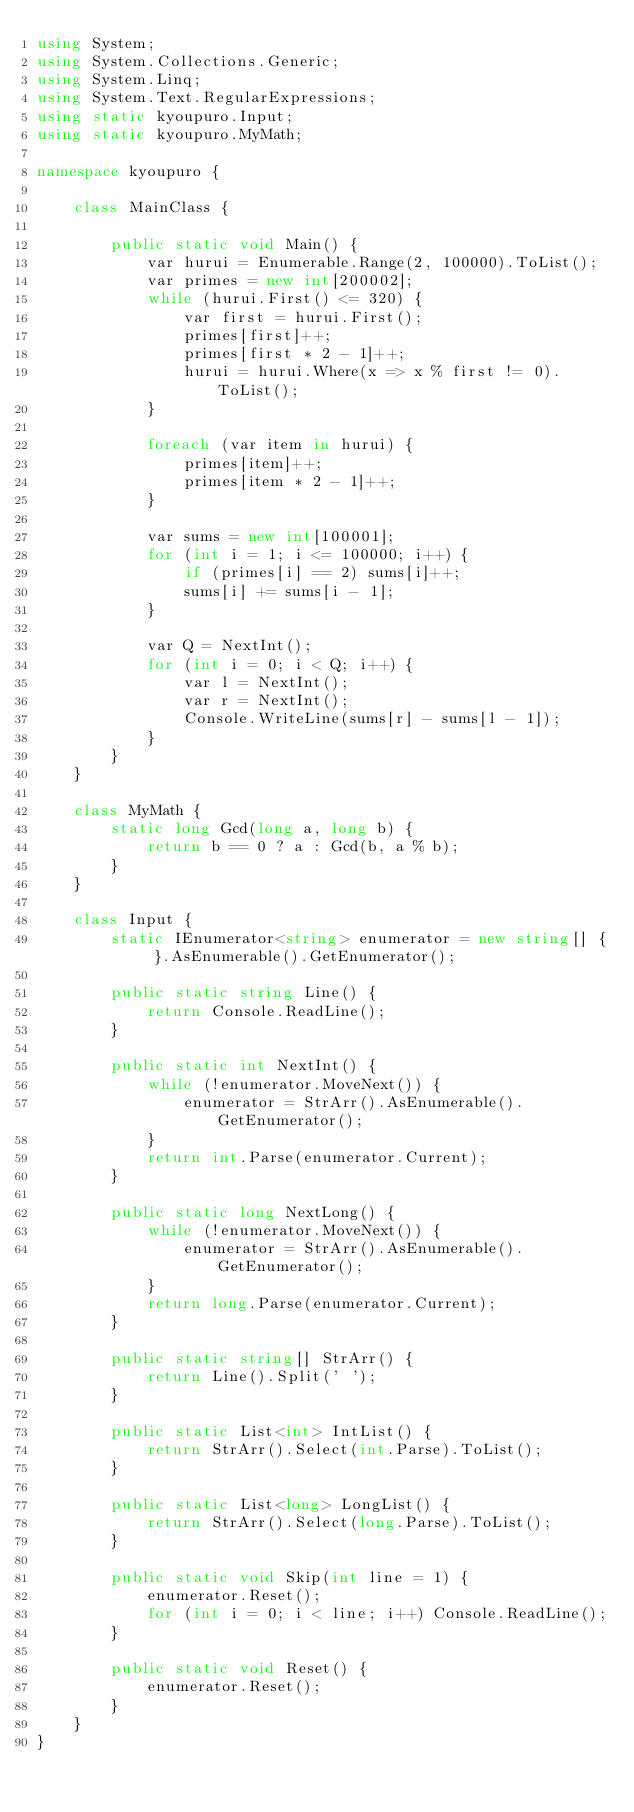Convert code to text. <code><loc_0><loc_0><loc_500><loc_500><_C#_>using System;
using System.Collections.Generic;
using System.Linq;
using System.Text.RegularExpressions;
using static kyoupuro.Input;
using static kyoupuro.MyMath;

namespace kyoupuro {

    class MainClass {

        public static void Main() {
            var hurui = Enumerable.Range(2, 100000).ToList();
            var primes = new int[200002];
            while (hurui.First() <= 320) {
                var first = hurui.First();
                primes[first]++;
                primes[first * 2 - 1]++;
                hurui = hurui.Where(x => x % first != 0).ToList();
            }

            foreach (var item in hurui) {
                primes[item]++;
                primes[item * 2 - 1]++;
            }

            var sums = new int[100001];
            for (int i = 1; i <= 100000; i++) {
                if (primes[i] == 2) sums[i]++;
                sums[i] += sums[i - 1];
            }

            var Q = NextInt();
            for (int i = 0; i < Q; i++) {
                var l = NextInt();
                var r = NextInt();
                Console.WriteLine(sums[r] - sums[l - 1]);
            }
        }
    }

    class MyMath {
        static long Gcd(long a, long b) {
            return b == 0 ? a : Gcd(b, a % b);
        }
    }

    class Input {
        static IEnumerator<string> enumerator = new string[] { }.AsEnumerable().GetEnumerator();

        public static string Line() {
            return Console.ReadLine();
        }

        public static int NextInt() {
            while (!enumerator.MoveNext()) {
                enumerator = StrArr().AsEnumerable().GetEnumerator();
            }
            return int.Parse(enumerator.Current);
        }

        public static long NextLong() {
            while (!enumerator.MoveNext()) {
                enumerator = StrArr().AsEnumerable().GetEnumerator();
            }
            return long.Parse(enumerator.Current);
        }

        public static string[] StrArr() {
            return Line().Split(' ');
        }

        public static List<int> IntList() {
            return StrArr().Select(int.Parse).ToList();
        }

        public static List<long> LongList() {
            return StrArr().Select(long.Parse).ToList();
        }

        public static void Skip(int line = 1) {
            enumerator.Reset();
            for (int i = 0; i < line; i++) Console.ReadLine();
        }

        public static void Reset() {
            enumerator.Reset();
        }
    }
}</code> 